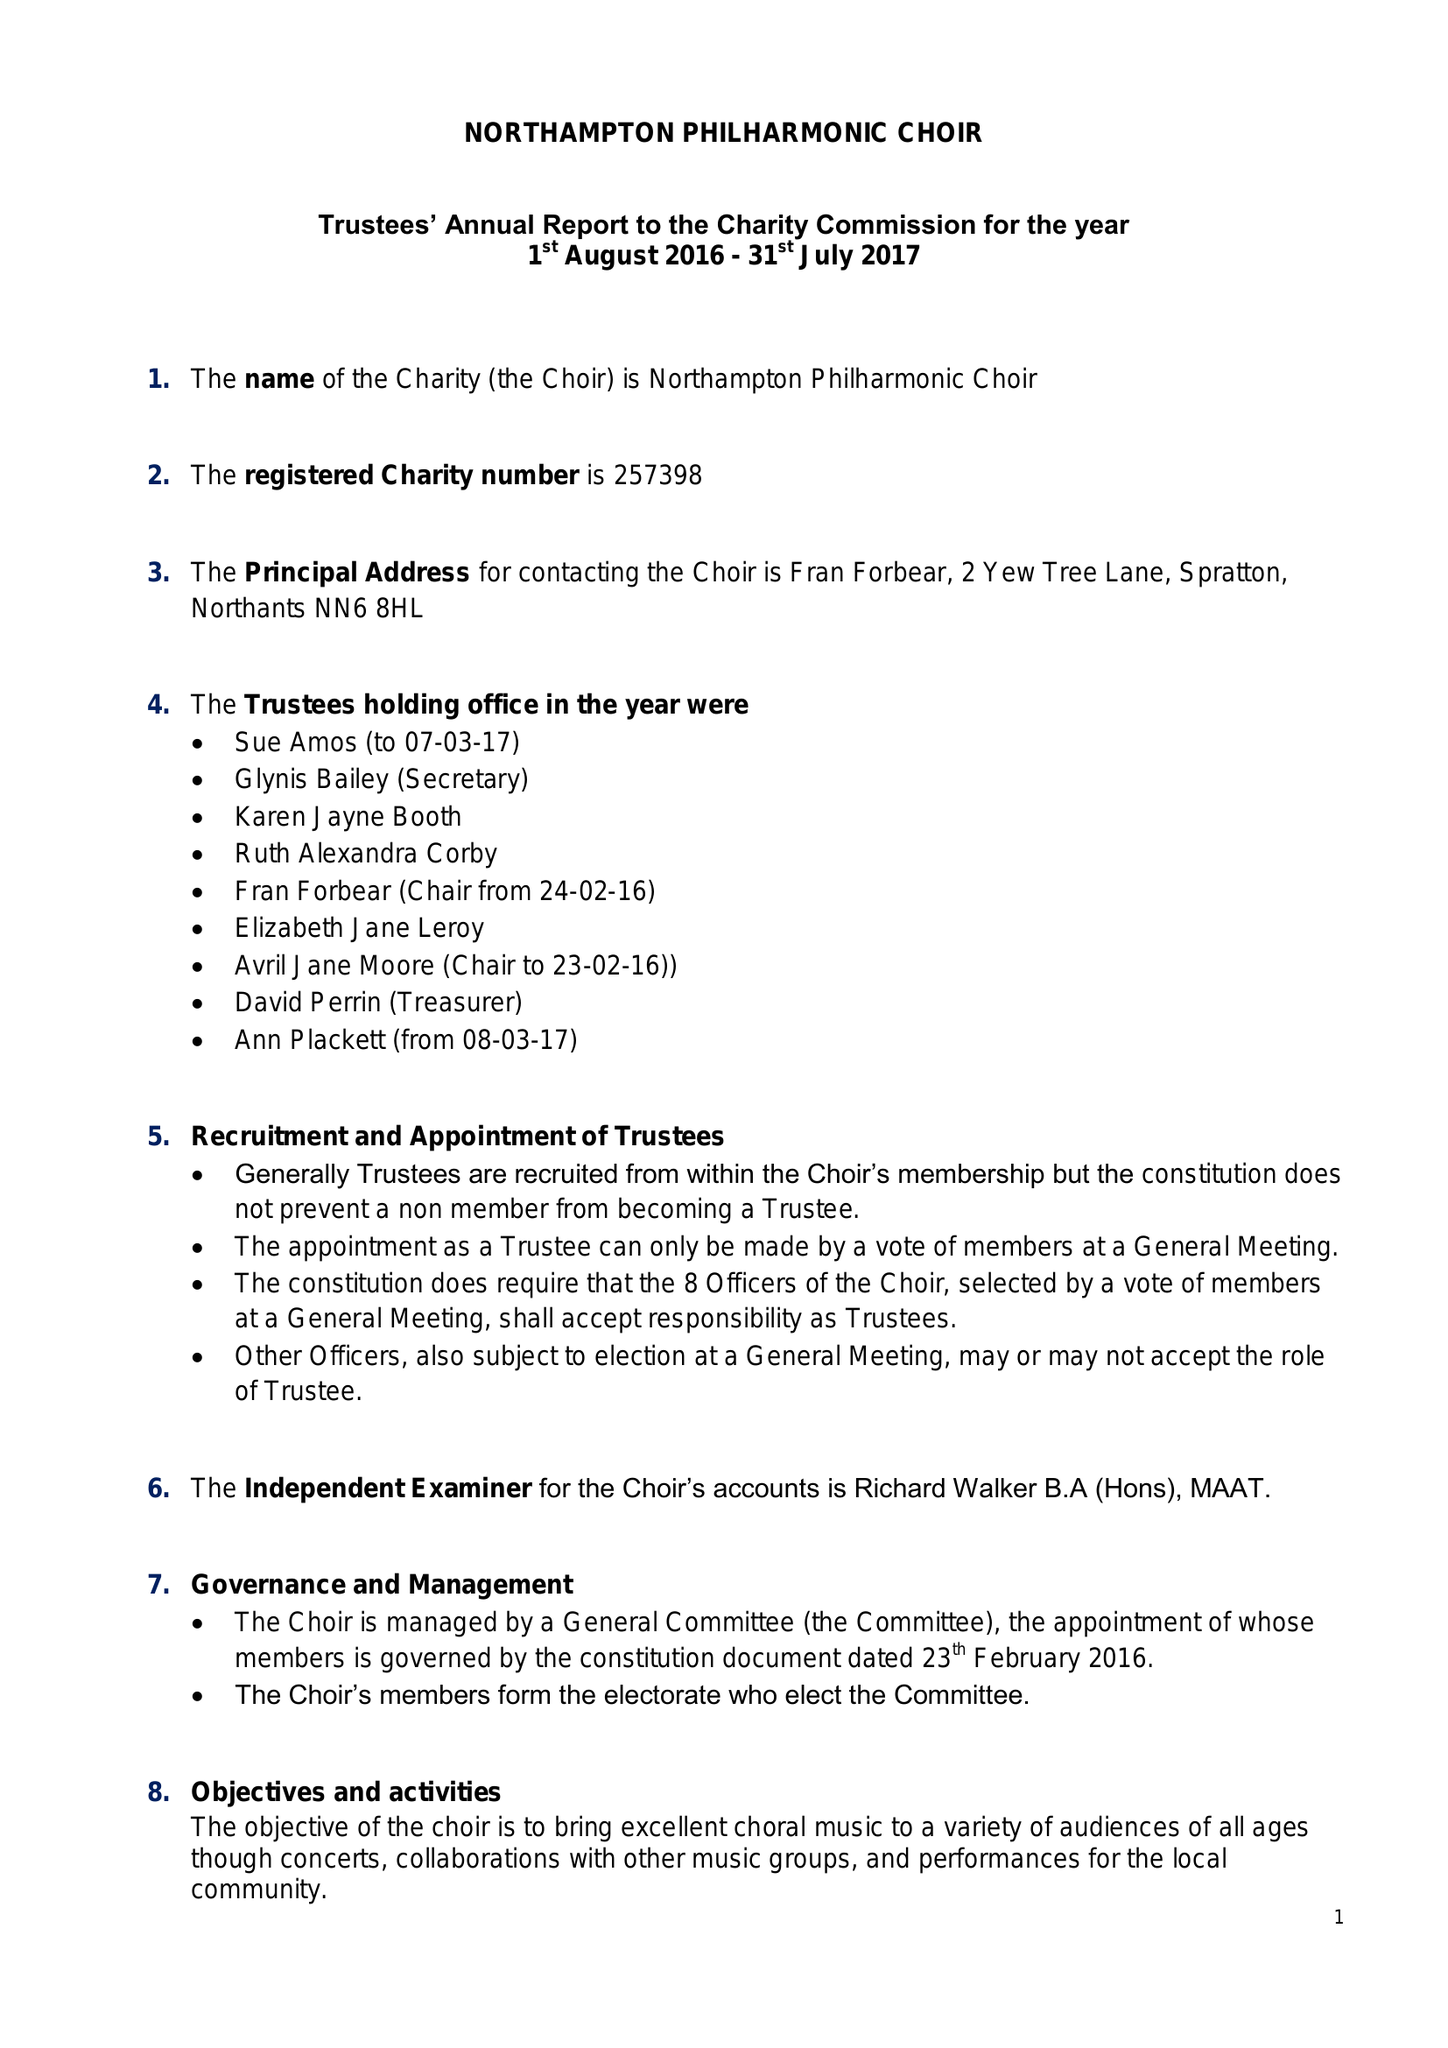What is the value for the charity_name?
Answer the question using a single word or phrase. Northampton Philharmonic Choir 